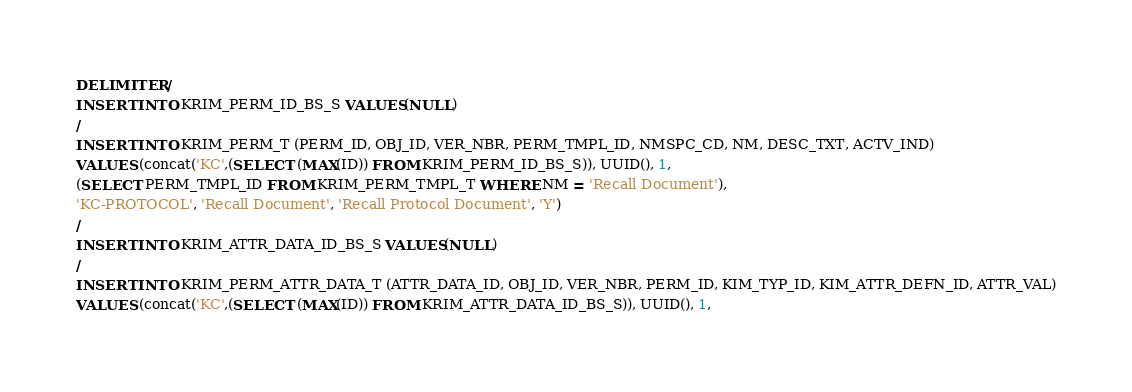Convert code to text. <code><loc_0><loc_0><loc_500><loc_500><_SQL_>DELIMITER /
INSERT INTO KRIM_PERM_ID_BS_S VALUES(NULL)
/
INSERT INTO KRIM_PERM_T (PERM_ID, OBJ_ID, VER_NBR, PERM_TMPL_ID, NMSPC_CD, NM, DESC_TXT, ACTV_IND)
VALUES (concat('KC',(SELECT (MAX(ID)) FROM KRIM_PERM_ID_BS_S)), UUID(), 1,
(SELECT PERM_TMPL_ID FROM KRIM_PERM_TMPL_T WHERE NM = 'Recall Document'),
'KC-PROTOCOL', 'Recall Document', 'Recall Protocol Document', 'Y')
/
INSERT INTO KRIM_ATTR_DATA_ID_BS_S VALUES(NULL)
/
INSERT INTO KRIM_PERM_ATTR_DATA_T (ATTR_DATA_ID, OBJ_ID, VER_NBR, PERM_ID, KIM_TYP_ID, KIM_ATTR_DEFN_ID, ATTR_VAL)
VALUES (concat('KC',(SELECT (MAX(ID)) FROM KRIM_ATTR_DATA_ID_BS_S)), UUID(), 1,</code> 